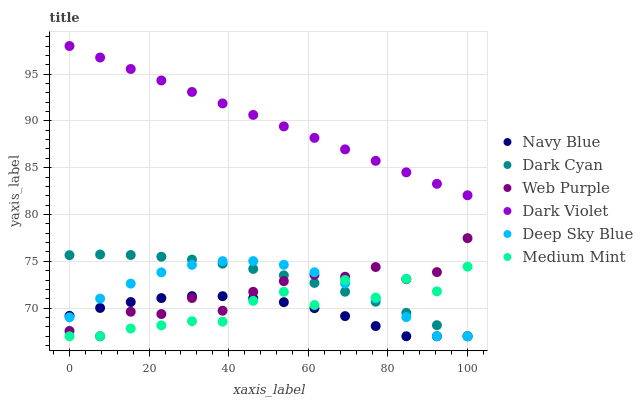Does Navy Blue have the minimum area under the curve?
Answer yes or no. Yes. Does Dark Violet have the maximum area under the curve?
Answer yes or no. Yes. Does Dark Violet have the minimum area under the curve?
Answer yes or no. No. Does Navy Blue have the maximum area under the curve?
Answer yes or no. No. Is Dark Violet the smoothest?
Answer yes or no. Yes. Is Medium Mint the roughest?
Answer yes or no. Yes. Is Navy Blue the smoothest?
Answer yes or no. No. Is Navy Blue the roughest?
Answer yes or no. No. Does Medium Mint have the lowest value?
Answer yes or no. Yes. Does Dark Violet have the lowest value?
Answer yes or no. No. Does Dark Violet have the highest value?
Answer yes or no. Yes. Does Navy Blue have the highest value?
Answer yes or no. No. Is Navy Blue less than Dark Violet?
Answer yes or no. Yes. Is Dark Violet greater than Navy Blue?
Answer yes or no. Yes. Does Deep Sky Blue intersect Navy Blue?
Answer yes or no. Yes. Is Deep Sky Blue less than Navy Blue?
Answer yes or no. No. Is Deep Sky Blue greater than Navy Blue?
Answer yes or no. No. Does Navy Blue intersect Dark Violet?
Answer yes or no. No. 